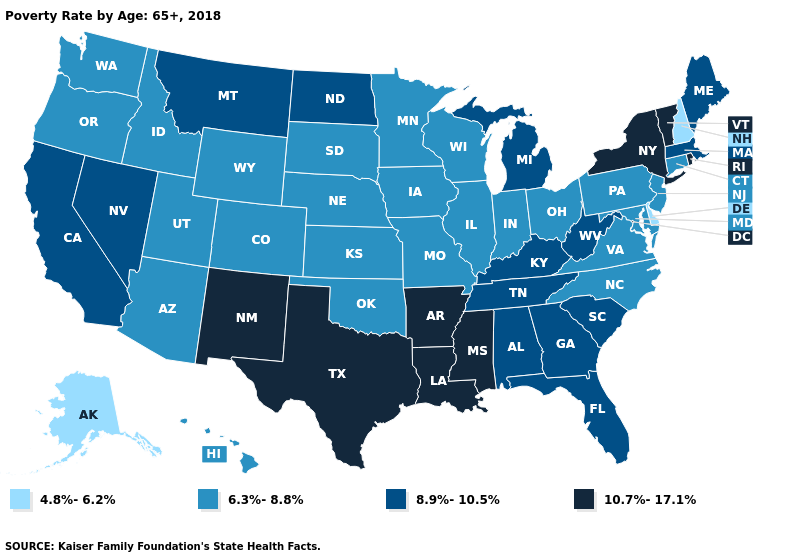Among the states that border Maine , which have the highest value?
Write a very short answer. New Hampshire. What is the value of New York?
Quick response, please. 10.7%-17.1%. What is the value of Montana?
Give a very brief answer. 8.9%-10.5%. What is the lowest value in the USA?
Short answer required. 4.8%-6.2%. Does Maine have the highest value in the USA?
Short answer required. No. Does the map have missing data?
Answer briefly. No. Among the states that border Kansas , which have the lowest value?
Concise answer only. Colorado, Missouri, Nebraska, Oklahoma. Does Maryland have a lower value than New Mexico?
Give a very brief answer. Yes. What is the value of Massachusetts?
Answer briefly. 8.9%-10.5%. Name the states that have a value in the range 8.9%-10.5%?
Quick response, please. Alabama, California, Florida, Georgia, Kentucky, Maine, Massachusetts, Michigan, Montana, Nevada, North Dakota, South Carolina, Tennessee, West Virginia. Which states hav the highest value in the West?
Be succinct. New Mexico. Does Louisiana have the same value as Vermont?
Give a very brief answer. Yes. Name the states that have a value in the range 6.3%-8.8%?
Give a very brief answer. Arizona, Colorado, Connecticut, Hawaii, Idaho, Illinois, Indiana, Iowa, Kansas, Maryland, Minnesota, Missouri, Nebraska, New Jersey, North Carolina, Ohio, Oklahoma, Oregon, Pennsylvania, South Dakota, Utah, Virginia, Washington, Wisconsin, Wyoming. What is the value of California?
Concise answer only. 8.9%-10.5%. What is the highest value in the USA?
Keep it brief. 10.7%-17.1%. 